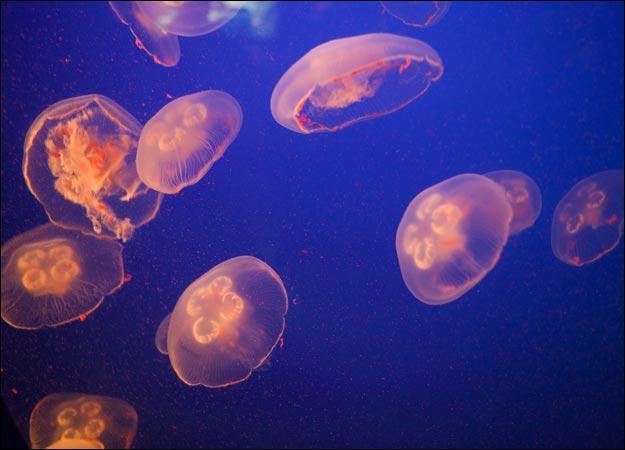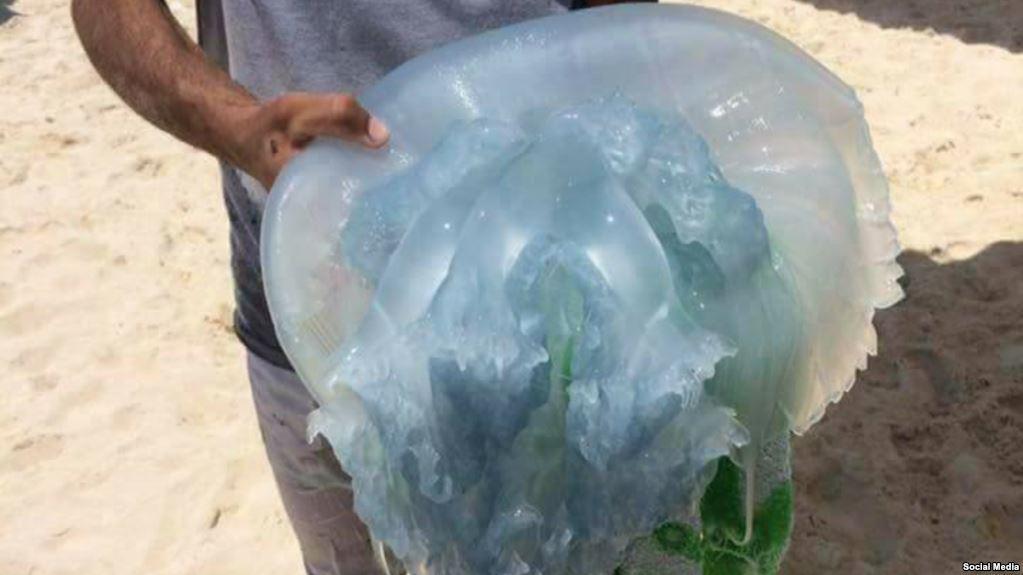The first image is the image on the left, the second image is the image on the right. Assess this claim about the two images: "A person is in one of the pictures.". Correct or not? Answer yes or no. Yes. The first image is the image on the left, the second image is the image on the right. Given the left and right images, does the statement "An image shows a human present with jellyfish." hold true? Answer yes or no. Yes. 